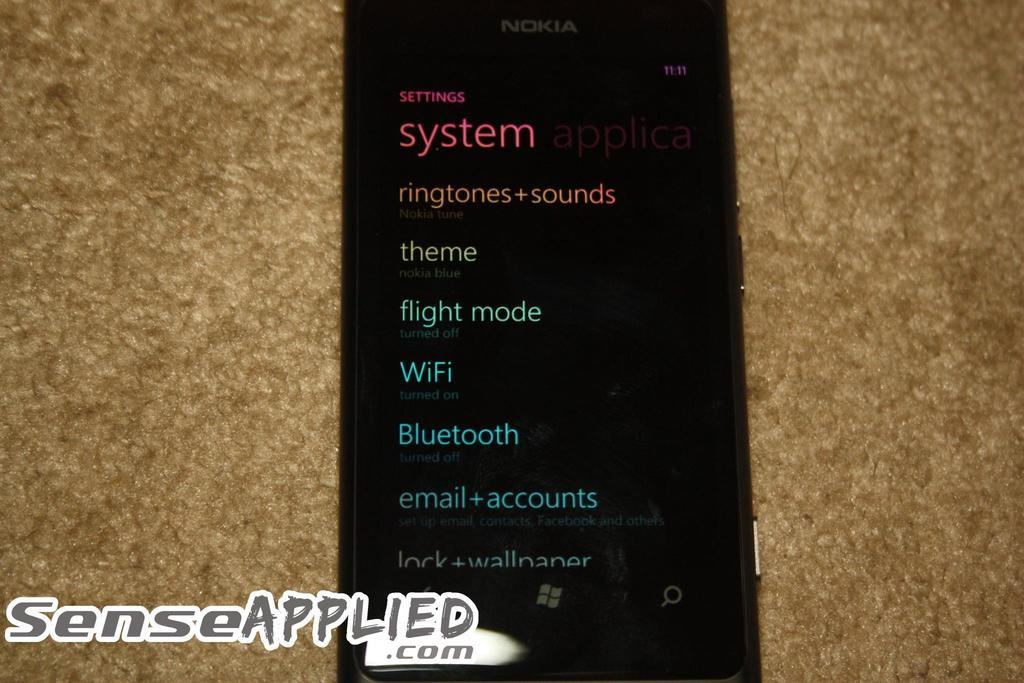What is the main object in the center of the image? There is a small book in the center of the image. Can you describe any text visible in the image? Yes, there is text at the bottom side of the image. How does the robin feel about the seat in the image? There is no robin present in the image, so it is not possible to determine how a robin might feel about a seat. 